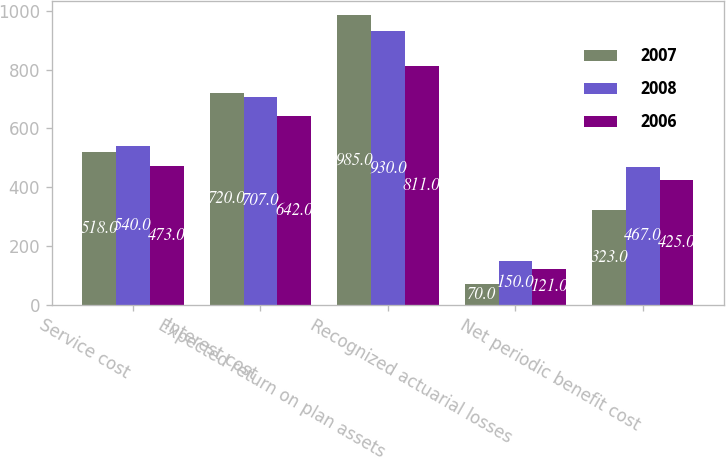Convert chart to OTSL. <chart><loc_0><loc_0><loc_500><loc_500><stacked_bar_chart><ecel><fcel>Service cost<fcel>Interest cost<fcel>Expected return on plan assets<fcel>Recognized actuarial losses<fcel>Net periodic benefit cost<nl><fcel>2007<fcel>518<fcel>720<fcel>985<fcel>70<fcel>323<nl><fcel>2008<fcel>540<fcel>707<fcel>930<fcel>150<fcel>467<nl><fcel>2006<fcel>473<fcel>642<fcel>811<fcel>121<fcel>425<nl></chart> 